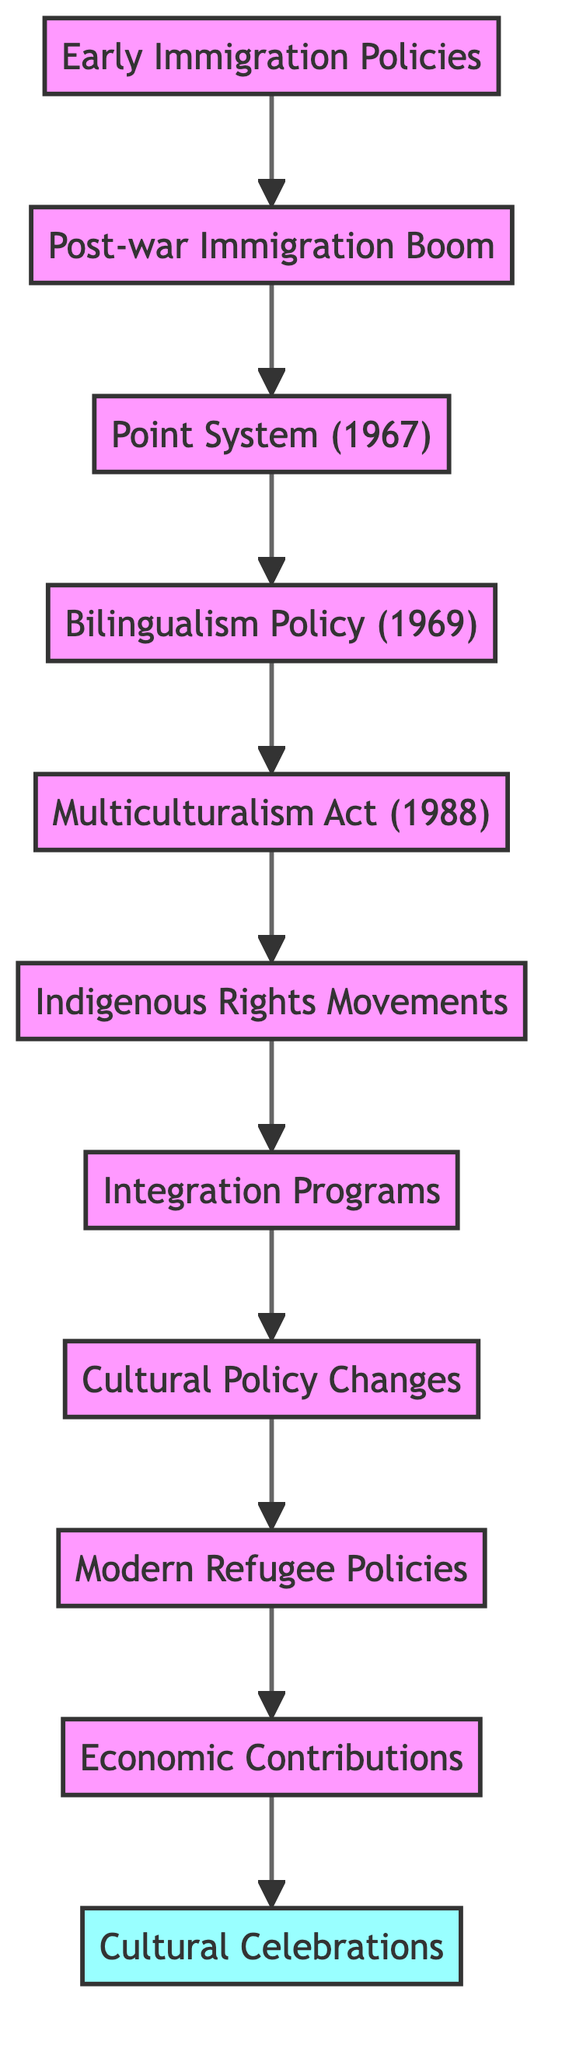What is the first node in the diagram? The first node in the diagram is "Early Immigration Policies," which is positioned at the bottom of the flowchart and serves as the starting point.
Answer: Early Immigration Policies How many total nodes are present in the diagram? The diagram contains 11 nodes, including all key elements related to the development of the Canadian identity through immigration, from "Early Immigration Policies" to "Cultural Celebrations."
Answer: 11 What is the relationship between "Point System (1967)" and "Post-war Immigration Boom"? "Point System (1967)" follows "Post-war Immigration Boom" in the flowchart, indicating the sequential development of immigration policies after the influx of European immigrants.
Answer: Point System (1967) follows Post-war Immigration Boom In which year was the "Multiculturalism Act" enacted? The "Multiculturalism Act" was enacted in 1988, which is directly mentioned in the node's description.
Answer: 1988 What is the last node in the diagram? The last node in the diagram is "Cultural Celebrations," which represents the culmination of the flowchart and emphasizes Canada's cultural diversity.
Answer: Cultural Celebrations Which node comes before "Integration Programs"? The node that comes before "Integration Programs" is "Indigenous Rights Movements," indicating a connection in the developmental sequence leading to integration initiatives for immigrants.
Answer: Indigenous Rights Movements How does "Economic Contributions" relate to "Modern Refugee Policies"? "Economic Contributions" follows "Modern Refugee Policies," depicting how policies regarding refugees contribute to the economic landscape and growth in Canada.
Answer: Economic Contributions follows Modern Refugee Policies What policy emphasizes Canada's official languages? The "Bilingualism Policy (1969)" emphasizes the promotion of both English and French as official languages, which is a key aspect of Canadian identity depicted in the diagram.
Answer: Bilingualism Policy (1969) Which two nodes represent legislation and policy shifts? "Multiculturalism Act (1988)" represents legislation, and "Cultural Policy Changes" represents policy shifts, reflecting governmental and societal adaptations over time.
Answer: Multiculturalism Act (1988) and Cultural Policy Changes 